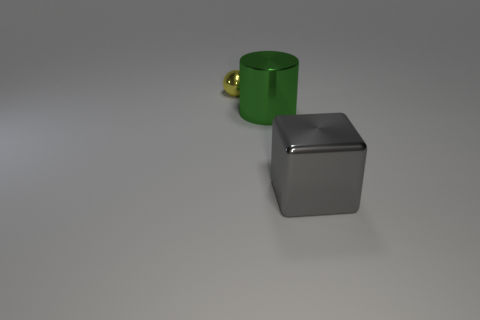Add 2 purple matte cylinders. How many objects exist? 5 Subtract all blocks. How many objects are left? 2 Add 2 large gray metal cubes. How many large gray metal cubes are left? 3 Add 1 blue matte spheres. How many blue matte spheres exist? 1 Subtract 0 blue blocks. How many objects are left? 3 Subtract all big green cylinders. Subtract all large green metallic cylinders. How many objects are left? 1 